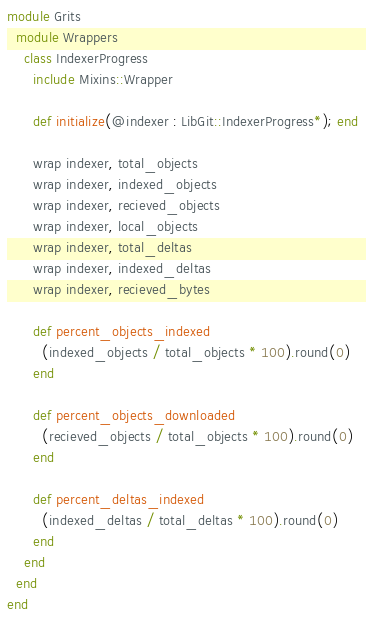<code> <loc_0><loc_0><loc_500><loc_500><_Crystal_>module Grits
  module Wrappers
    class IndexerProgress
      include Mixins::Wrapper

      def initialize(@indexer : LibGit::IndexerProgress*); end

      wrap indexer, total_objects
      wrap indexer, indexed_objects
      wrap indexer, recieved_objects
      wrap indexer, local_objects
      wrap indexer, total_deltas
      wrap indexer, indexed_deltas
      wrap indexer, recieved_bytes

      def percent_objects_indexed
        (indexed_objects / total_objects * 100).round(0)
      end

      def percent_objects_downloaded
        (recieved_objects / total_objects * 100).round(0)
      end

      def percent_deltas_indexed
        (indexed_deltas / total_deltas * 100).round(0)
      end
    end
  end
end</code> 